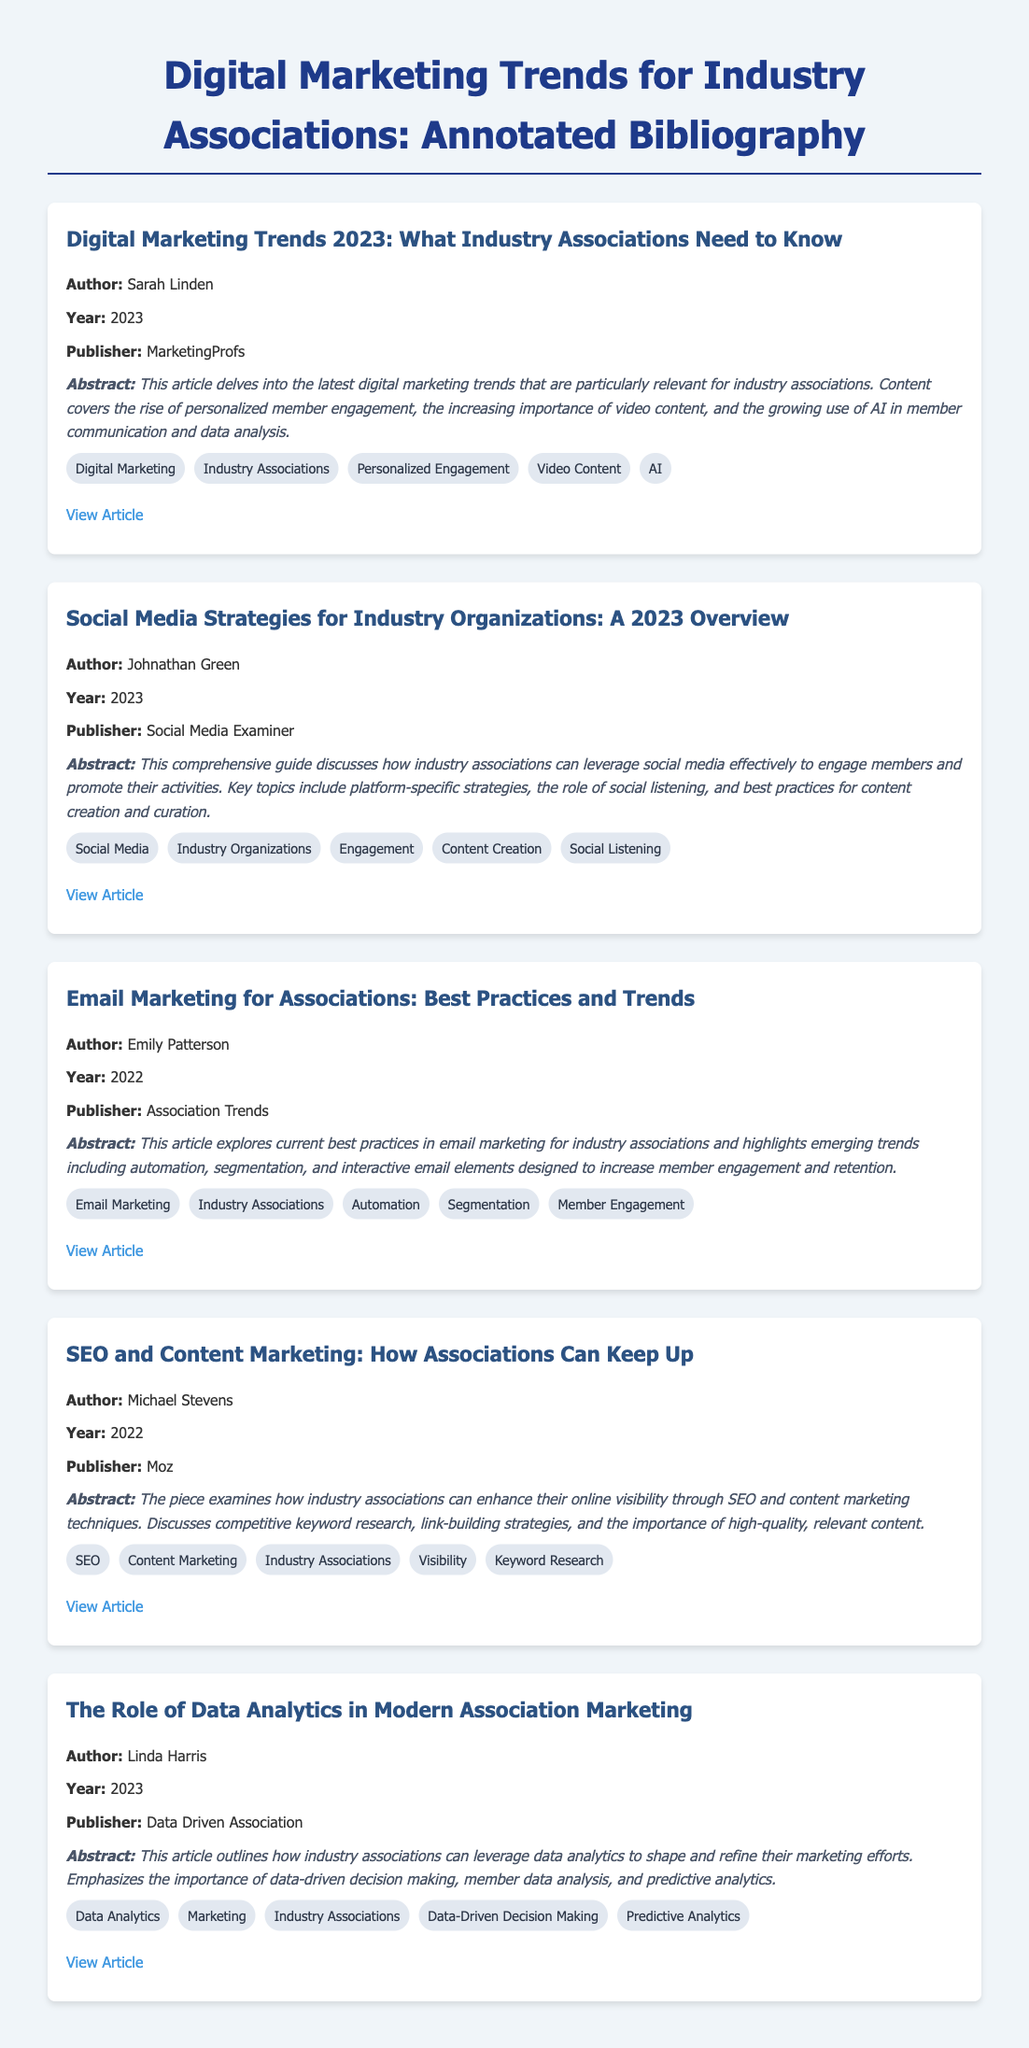What is the title of the first entry? The title of the first entry is listed at the top of the section under the author's name and year, which is "Digital Marketing Trends 2023: What Industry Associations Need to Know".
Answer: Digital Marketing Trends 2023: What Industry Associations Need to Know Who is the author of "SEO and Content Marketing: How Associations Can Keep Up"? The author is stated clearly in the entry details for "SEO and Content Marketing: How Associations Can Keep Up", which is Michael Stevens.
Answer: Michael Stevens In what year was the article by Emily Patterson published? The year is specified directly under the author's name in the article entry for email marketing best practices, which states 2022.
Answer: 2022 What is one keyword associated with the article on social media strategies? The keywords are listed at the bottom of the article entry, one of which is Social Media.
Answer: Social Media How many articles were published in 2023? The document provides the publication years in each entry, with two articles indicating they were published in the year 2023.
Answer: 2 What publisher released the article discussing data analytics in association marketing? The publisher's name is given in the entry where Linda Harris's article is detailed, which is Data Driven Association.
Answer: Data Driven Association What digital marketing trend does Sarah Linden highlight in her article? The trend details are included in the abstract of the article, where personalized member engagement is identified as important.
Answer: Personalized member engagement Which article discusses email automation? The article titled "Email Marketing for Associations: Best Practices and Trends" specifically addresses email automation in its content.
Answer: Email Marketing for Associations: Best Practices and Trends What type of document is this? The document is a structured summary of sources about digital marketing that provides information about authors, years, abstracts, and keywords, typically referred to as annotated bibliography.
Answer: Annotated Bibliography 